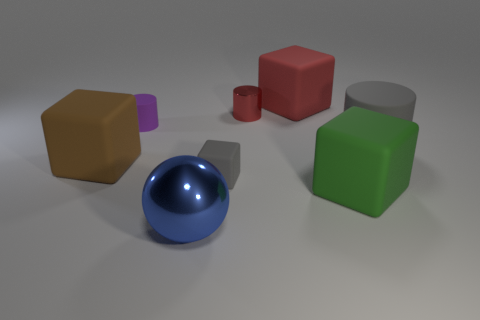The block that is both on the right side of the brown matte thing and left of the small red metallic object is made of what material?
Keep it short and to the point. Rubber. The other small object that is the same shape as the brown matte thing is what color?
Offer a very short reply. Gray. How big is the green rubber object?
Offer a terse response. Large. The big matte block that is in front of the large matte thing left of the blue sphere is what color?
Keep it short and to the point. Green. How many metal objects are both behind the tiny matte cube and in front of the purple thing?
Your answer should be very brief. 0. Is the number of big purple cubes greater than the number of big rubber things?
Your response must be concise. No. What material is the red cube?
Provide a short and direct response. Rubber. What number of large brown rubber things are behind the small rubber thing on the left side of the blue metallic sphere?
Ensure brevity in your answer.  0. Do the tiny cube and the cylinder to the right of the red cube have the same color?
Your response must be concise. Yes. The cylinder that is the same size as the brown rubber object is what color?
Give a very brief answer. Gray. 